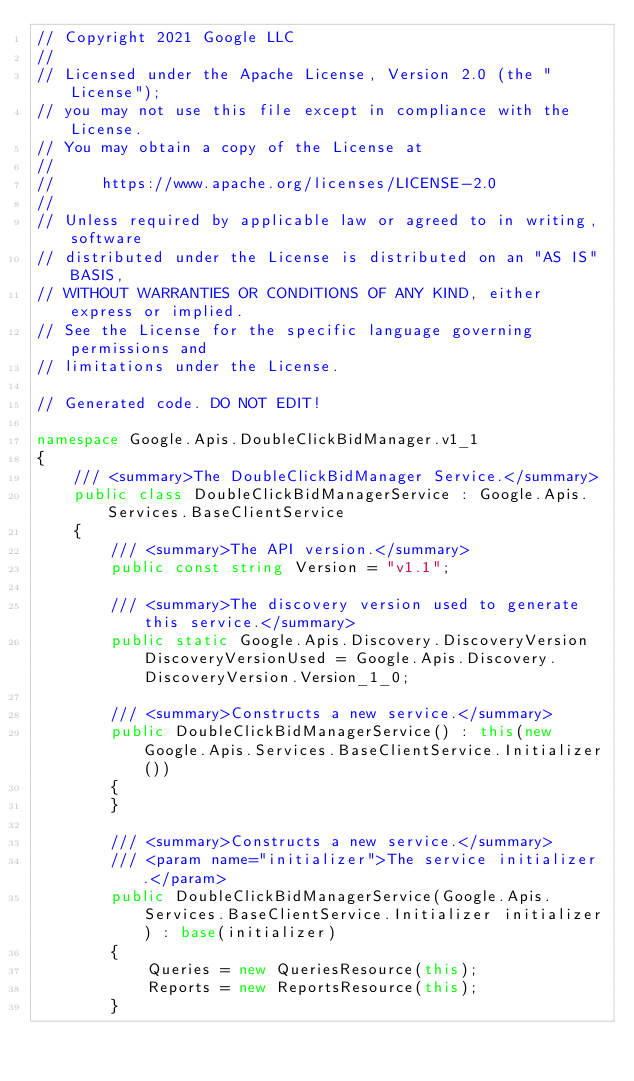Convert code to text. <code><loc_0><loc_0><loc_500><loc_500><_C#_>// Copyright 2021 Google LLC
//
// Licensed under the Apache License, Version 2.0 (the "License");
// you may not use this file except in compliance with the License.
// You may obtain a copy of the License at
//
//     https://www.apache.org/licenses/LICENSE-2.0
//
// Unless required by applicable law or agreed to in writing, software
// distributed under the License is distributed on an "AS IS" BASIS,
// WITHOUT WARRANTIES OR CONDITIONS OF ANY KIND, either express or implied.
// See the License for the specific language governing permissions and
// limitations under the License.

// Generated code. DO NOT EDIT!

namespace Google.Apis.DoubleClickBidManager.v1_1
{
    /// <summary>The DoubleClickBidManager Service.</summary>
    public class DoubleClickBidManagerService : Google.Apis.Services.BaseClientService
    {
        /// <summary>The API version.</summary>
        public const string Version = "v1.1";

        /// <summary>The discovery version used to generate this service.</summary>
        public static Google.Apis.Discovery.DiscoveryVersion DiscoveryVersionUsed = Google.Apis.Discovery.DiscoveryVersion.Version_1_0;

        /// <summary>Constructs a new service.</summary>
        public DoubleClickBidManagerService() : this(new Google.Apis.Services.BaseClientService.Initializer())
        {
        }

        /// <summary>Constructs a new service.</summary>
        /// <param name="initializer">The service initializer.</param>
        public DoubleClickBidManagerService(Google.Apis.Services.BaseClientService.Initializer initializer) : base(initializer)
        {
            Queries = new QueriesResource(this);
            Reports = new ReportsResource(this);
        }
</code> 